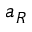Convert formula to latex. <formula><loc_0><loc_0><loc_500><loc_500>a _ { R }</formula> 